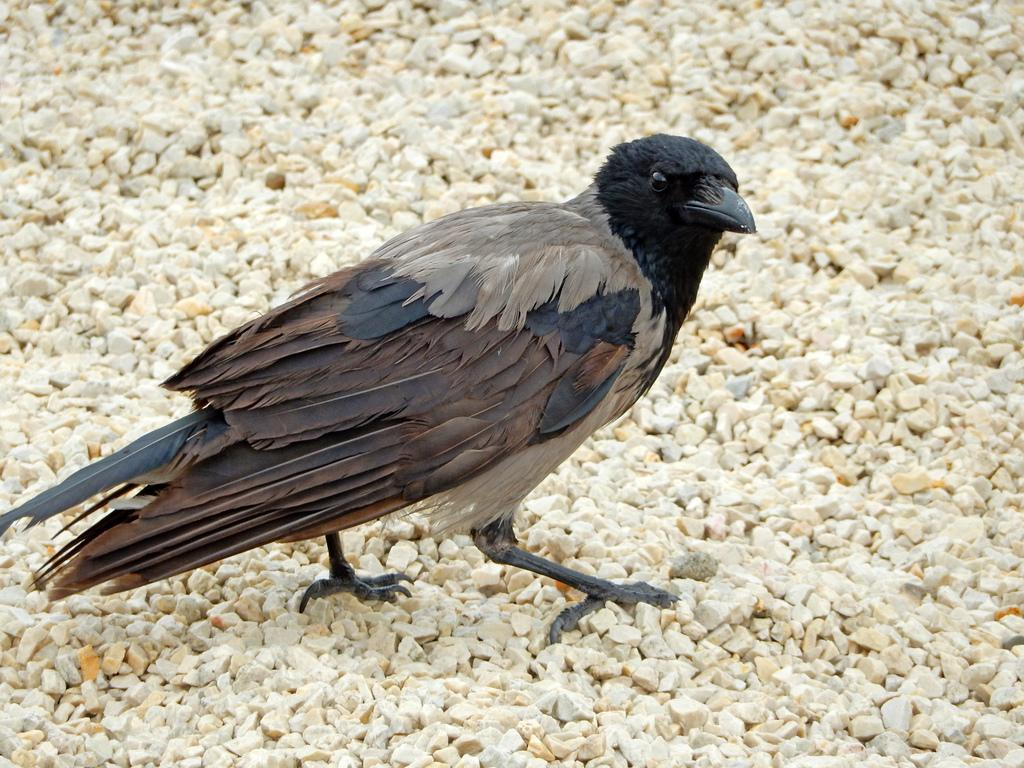What is the main subject in the center of the image? There is a bird in the center of the image. What can be seen at the bottom of the image? There are stones at the bottom of the image. What role does the actor play in the image? There is no actor present in the image; it features a bird and stones. What is the maid doing in the image? There is no maid present in the image. 